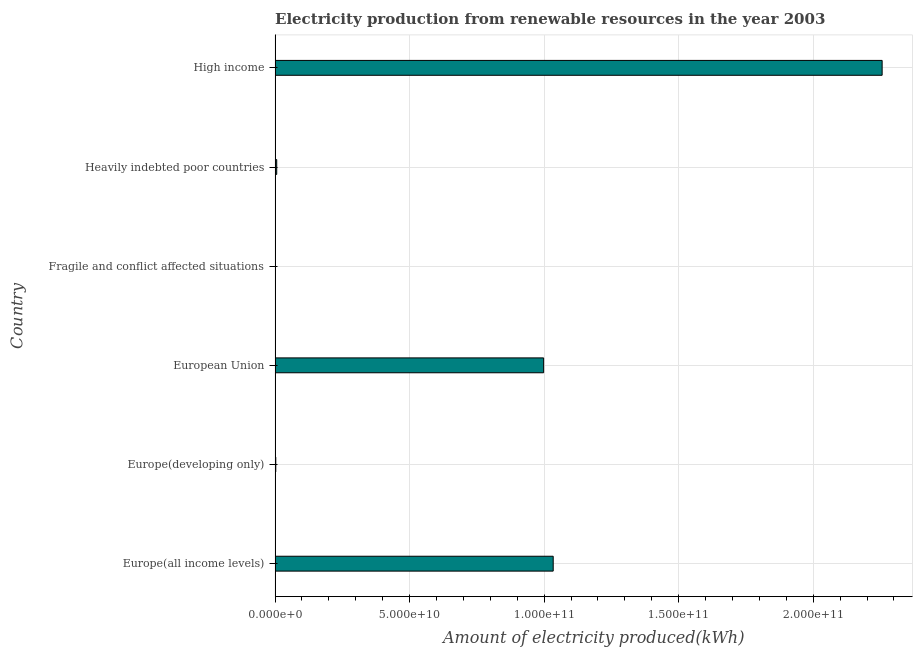Does the graph contain any zero values?
Offer a terse response. No. Does the graph contain grids?
Make the answer very short. Yes. What is the title of the graph?
Your answer should be compact. Electricity production from renewable resources in the year 2003. What is the label or title of the X-axis?
Your response must be concise. Amount of electricity produced(kWh). What is the amount of electricity produced in Heavily indebted poor countries?
Your answer should be compact. 6.09e+08. Across all countries, what is the maximum amount of electricity produced?
Keep it short and to the point. 2.26e+11. In which country was the amount of electricity produced maximum?
Give a very brief answer. High income. In which country was the amount of electricity produced minimum?
Keep it short and to the point. Fragile and conflict affected situations. What is the sum of the amount of electricity produced?
Keep it short and to the point. 4.30e+11. What is the difference between the amount of electricity produced in Europe(developing only) and Heavily indebted poor countries?
Provide a short and direct response. -3.46e+08. What is the average amount of electricity produced per country?
Offer a very short reply. 7.16e+1. What is the median amount of electricity produced?
Provide a short and direct response. 5.02e+1. What is the ratio of the amount of electricity produced in Europe(all income levels) to that in Heavily indebted poor countries?
Give a very brief answer. 169.73. Is the difference between the amount of electricity produced in European Union and Heavily indebted poor countries greater than the difference between any two countries?
Offer a very short reply. No. What is the difference between the highest and the second highest amount of electricity produced?
Your answer should be compact. 1.22e+11. Is the sum of the amount of electricity produced in Europe(all income levels) and Heavily indebted poor countries greater than the maximum amount of electricity produced across all countries?
Make the answer very short. No. What is the difference between the highest and the lowest amount of electricity produced?
Provide a short and direct response. 2.26e+11. In how many countries, is the amount of electricity produced greater than the average amount of electricity produced taken over all countries?
Give a very brief answer. 3. How many countries are there in the graph?
Give a very brief answer. 6. What is the Amount of electricity produced(kWh) in Europe(all income levels)?
Ensure brevity in your answer.  1.03e+11. What is the Amount of electricity produced(kWh) in Europe(developing only)?
Offer a terse response. 2.63e+08. What is the Amount of electricity produced(kWh) in European Union?
Your answer should be very brief. 9.98e+1. What is the Amount of electricity produced(kWh) in Fragile and conflict affected situations?
Make the answer very short. 3.00e+06. What is the Amount of electricity produced(kWh) in Heavily indebted poor countries?
Give a very brief answer. 6.09e+08. What is the Amount of electricity produced(kWh) of High income?
Your answer should be compact. 2.26e+11. What is the difference between the Amount of electricity produced(kWh) in Europe(all income levels) and Europe(developing only)?
Ensure brevity in your answer.  1.03e+11. What is the difference between the Amount of electricity produced(kWh) in Europe(all income levels) and European Union?
Ensure brevity in your answer.  3.56e+09. What is the difference between the Amount of electricity produced(kWh) in Europe(all income levels) and Fragile and conflict affected situations?
Keep it short and to the point. 1.03e+11. What is the difference between the Amount of electricity produced(kWh) in Europe(all income levels) and Heavily indebted poor countries?
Keep it short and to the point. 1.03e+11. What is the difference between the Amount of electricity produced(kWh) in Europe(all income levels) and High income?
Provide a short and direct response. -1.22e+11. What is the difference between the Amount of electricity produced(kWh) in Europe(developing only) and European Union?
Provide a succinct answer. -9.95e+1. What is the difference between the Amount of electricity produced(kWh) in Europe(developing only) and Fragile and conflict affected situations?
Provide a short and direct response. 2.60e+08. What is the difference between the Amount of electricity produced(kWh) in Europe(developing only) and Heavily indebted poor countries?
Your answer should be compact. -3.46e+08. What is the difference between the Amount of electricity produced(kWh) in Europe(developing only) and High income?
Give a very brief answer. -2.25e+11. What is the difference between the Amount of electricity produced(kWh) in European Union and Fragile and conflict affected situations?
Give a very brief answer. 9.98e+1. What is the difference between the Amount of electricity produced(kWh) in European Union and Heavily indebted poor countries?
Provide a short and direct response. 9.92e+1. What is the difference between the Amount of electricity produced(kWh) in European Union and High income?
Your answer should be compact. -1.26e+11. What is the difference between the Amount of electricity produced(kWh) in Fragile and conflict affected situations and Heavily indebted poor countries?
Your answer should be very brief. -6.06e+08. What is the difference between the Amount of electricity produced(kWh) in Fragile and conflict affected situations and High income?
Your answer should be compact. -2.26e+11. What is the difference between the Amount of electricity produced(kWh) in Heavily indebted poor countries and High income?
Provide a short and direct response. -2.25e+11. What is the ratio of the Amount of electricity produced(kWh) in Europe(all income levels) to that in Europe(developing only)?
Offer a terse response. 393.03. What is the ratio of the Amount of electricity produced(kWh) in Europe(all income levels) to that in European Union?
Provide a short and direct response. 1.04. What is the ratio of the Amount of electricity produced(kWh) in Europe(all income levels) to that in Fragile and conflict affected situations?
Ensure brevity in your answer.  3.45e+04. What is the ratio of the Amount of electricity produced(kWh) in Europe(all income levels) to that in Heavily indebted poor countries?
Provide a succinct answer. 169.73. What is the ratio of the Amount of electricity produced(kWh) in Europe(all income levels) to that in High income?
Your answer should be compact. 0.46. What is the ratio of the Amount of electricity produced(kWh) in Europe(developing only) to that in European Union?
Your response must be concise. 0. What is the ratio of the Amount of electricity produced(kWh) in Europe(developing only) to that in Fragile and conflict affected situations?
Provide a short and direct response. 87.67. What is the ratio of the Amount of electricity produced(kWh) in Europe(developing only) to that in Heavily indebted poor countries?
Your response must be concise. 0.43. What is the ratio of the Amount of electricity produced(kWh) in Europe(developing only) to that in High income?
Provide a succinct answer. 0. What is the ratio of the Amount of electricity produced(kWh) in European Union to that in Fragile and conflict affected situations?
Provide a succinct answer. 3.33e+04. What is the ratio of the Amount of electricity produced(kWh) in European Union to that in Heavily indebted poor countries?
Provide a succinct answer. 163.89. What is the ratio of the Amount of electricity produced(kWh) in European Union to that in High income?
Give a very brief answer. 0.44. What is the ratio of the Amount of electricity produced(kWh) in Fragile and conflict affected situations to that in Heavily indebted poor countries?
Your response must be concise. 0.01. What is the ratio of the Amount of electricity produced(kWh) in Heavily indebted poor countries to that in High income?
Provide a succinct answer. 0. 